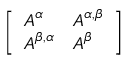<formula> <loc_0><loc_0><loc_500><loc_500>\left [ \begin{array} { l l } { A ^ { \alpha } } & { A ^ { \alpha , \beta } } \\ { A ^ { \beta , \alpha } } & { A ^ { \beta } } \end{array} \right ]</formula> 